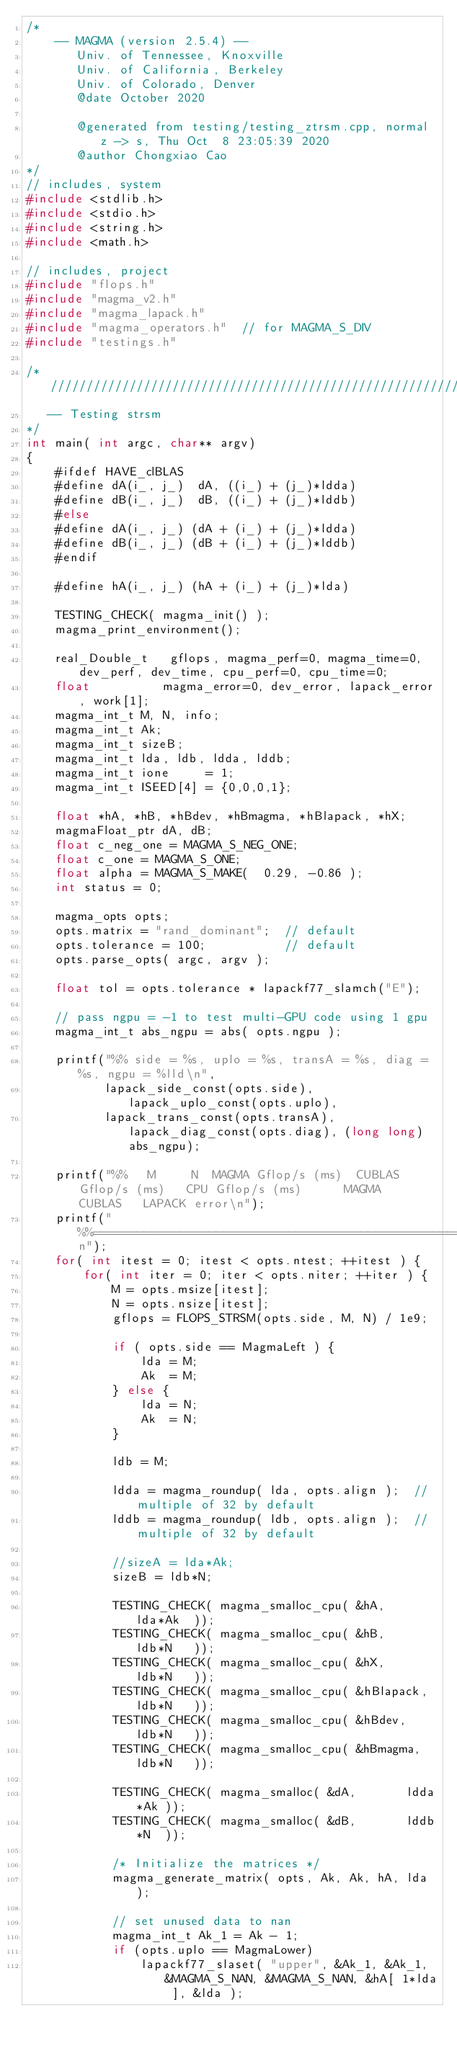Convert code to text. <code><loc_0><loc_0><loc_500><loc_500><_C++_>/*
    -- MAGMA (version 2.5.4) --
       Univ. of Tennessee, Knoxville
       Univ. of California, Berkeley
       Univ. of Colorado, Denver
       @date October 2020

       @generated from testing/testing_ztrsm.cpp, normal z -> s, Thu Oct  8 23:05:39 2020
       @author Chongxiao Cao
*/
// includes, system
#include <stdlib.h>
#include <stdio.h>
#include <string.h>
#include <math.h>

// includes, project
#include "flops.h"
#include "magma_v2.h"
#include "magma_lapack.h"
#include "magma_operators.h"  // for MAGMA_S_DIV
#include "testings.h"

/* ////////////////////////////////////////////////////////////////////////////
   -- Testing strsm
*/
int main( int argc, char** argv)
{
    #ifdef HAVE_clBLAS
    #define dA(i_, j_)  dA, ((i_) + (j_)*ldda)
    #define dB(i_, j_)  dB, ((i_) + (j_)*lddb)
    #else
    #define dA(i_, j_) (dA + (i_) + (j_)*ldda)
    #define dB(i_, j_) (dB + (i_) + (j_)*lddb)
    #endif

    #define hA(i_, j_) (hA + (i_) + (j_)*lda)

    TESTING_CHECK( magma_init() );
    magma_print_environment();

    real_Double_t   gflops, magma_perf=0, magma_time=0, dev_perf, dev_time, cpu_perf=0, cpu_time=0;
    float          magma_error=0, dev_error, lapack_error, work[1];
    magma_int_t M, N, info;
    magma_int_t Ak;
    magma_int_t sizeB;
    magma_int_t lda, ldb, ldda, lddb;
    magma_int_t ione     = 1;
    magma_int_t ISEED[4] = {0,0,0,1};

    float *hA, *hB, *hBdev, *hBmagma, *hBlapack, *hX;
    magmaFloat_ptr dA, dB;
    float c_neg_one = MAGMA_S_NEG_ONE;
    float c_one = MAGMA_S_ONE;
    float alpha = MAGMA_S_MAKE(  0.29, -0.86 );
    int status = 0;

    magma_opts opts;
    opts.matrix = "rand_dominant";  // default
    opts.tolerance = 100;           // default
    opts.parse_opts( argc, argv );

    float tol = opts.tolerance * lapackf77_slamch("E");

    // pass ngpu = -1 to test multi-GPU code using 1 gpu
    magma_int_t abs_ngpu = abs( opts.ngpu );

    printf("%% side = %s, uplo = %s, transA = %s, diag = %s, ngpu = %lld\n",
           lapack_side_const(opts.side), lapack_uplo_const(opts.uplo),
           lapack_trans_const(opts.transA), lapack_diag_const(opts.diag), (long long) abs_ngpu);

    printf("%%   M     N  MAGMA Gflop/s (ms)  CUBLAS Gflop/s (ms)   CPU Gflop/s (ms)      MAGMA     CUBLAS   LAPACK error\n");
    printf("%%============================================================================================================\n");
    for( int itest = 0; itest < opts.ntest; ++itest ) {
        for( int iter = 0; iter < opts.niter; ++iter ) {
            M = opts.msize[itest];
            N = opts.nsize[itest];
            gflops = FLOPS_STRSM(opts.side, M, N) / 1e9;

            if ( opts.side == MagmaLeft ) {
                lda = M;
                Ak  = M;
            } else {
                lda = N;
                Ak  = N;
            }

            ldb = M;

            ldda = magma_roundup( lda, opts.align );  // multiple of 32 by default
            lddb = magma_roundup( ldb, opts.align );  // multiple of 32 by default

            //sizeA = lda*Ak;
            sizeB = ldb*N;

            TESTING_CHECK( magma_smalloc_cpu( &hA,       lda*Ak  ));
            TESTING_CHECK( magma_smalloc_cpu( &hB,       ldb*N   ));
            TESTING_CHECK( magma_smalloc_cpu( &hX,       ldb*N   ));
            TESTING_CHECK( magma_smalloc_cpu( &hBlapack, ldb*N   ));
            TESTING_CHECK( magma_smalloc_cpu( &hBdev,    ldb*N   ));
            TESTING_CHECK( magma_smalloc_cpu( &hBmagma,  ldb*N   ));

            TESTING_CHECK( magma_smalloc( &dA,       ldda*Ak ));
            TESTING_CHECK( magma_smalloc( &dB,       lddb*N  ));

            /* Initialize the matrices */
            magma_generate_matrix( opts, Ak, Ak, hA, lda );

            // set unused data to nan
            magma_int_t Ak_1 = Ak - 1;
            if (opts.uplo == MagmaLower)
                lapackf77_slaset( "upper", &Ak_1, &Ak_1, &MAGMA_S_NAN, &MAGMA_S_NAN, &hA[ 1*lda ], &lda );</code> 